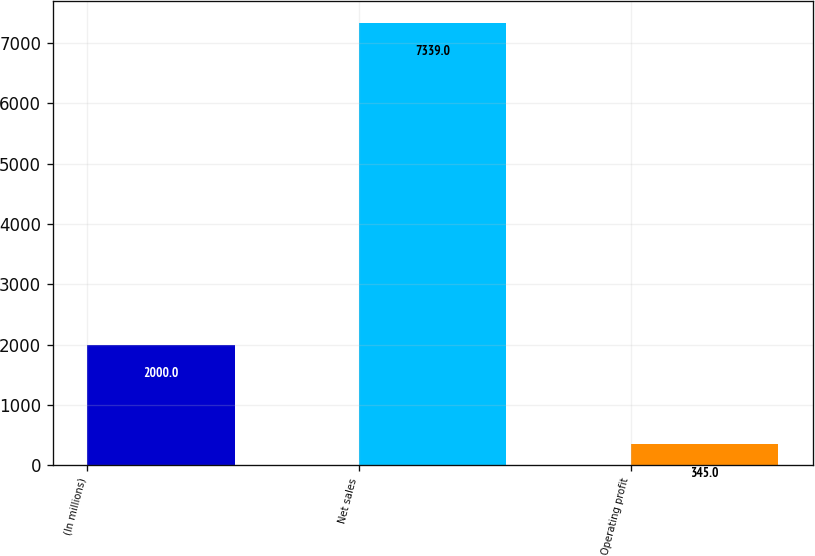Convert chart. <chart><loc_0><loc_0><loc_500><loc_500><bar_chart><fcel>(In millions)<fcel>Net sales<fcel>Operating profit<nl><fcel>2000<fcel>7339<fcel>345<nl></chart> 